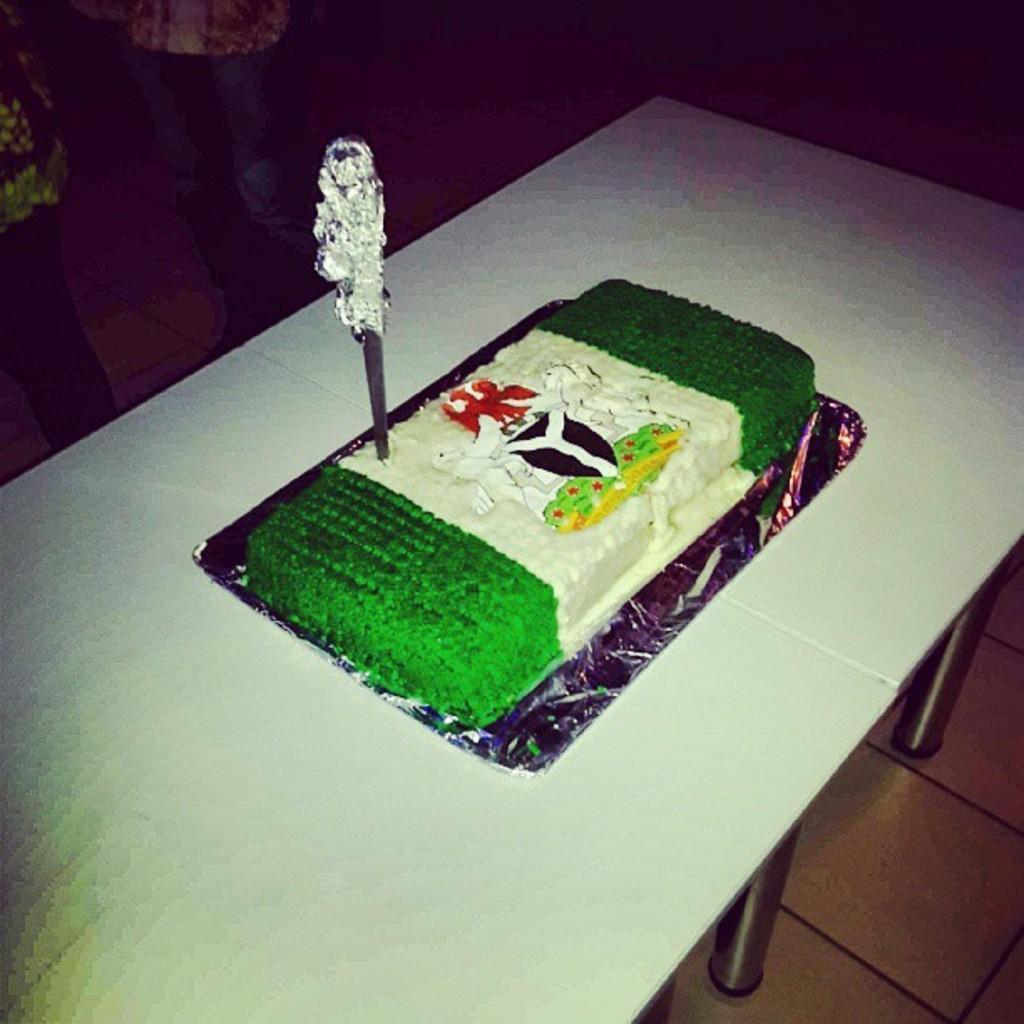Please provide a concise description of this image. In this picture I can see a cake on the tables, there is a knife poked into the cake, and in the background I think there is a person standing. 